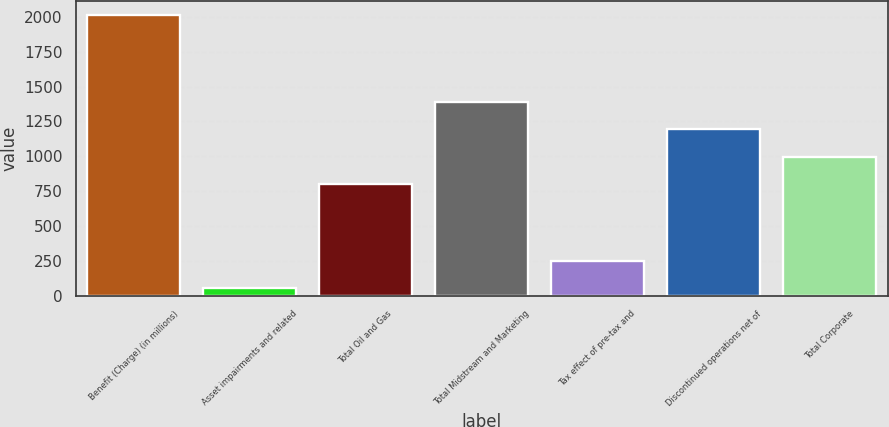Convert chart to OTSL. <chart><loc_0><loc_0><loc_500><loc_500><bar_chart><fcel>Benefit (Charge) (in millions)<fcel>Asset impairments and related<fcel>Total Oil and Gas<fcel>Total Midstream and Marketing<fcel>Tax effect of pre-tax and<fcel>Discontinued operations net of<fcel>Total Corporate<nl><fcel>2013<fcel>58<fcel>802.5<fcel>1389<fcel>253.5<fcel>1193.5<fcel>998<nl></chart> 